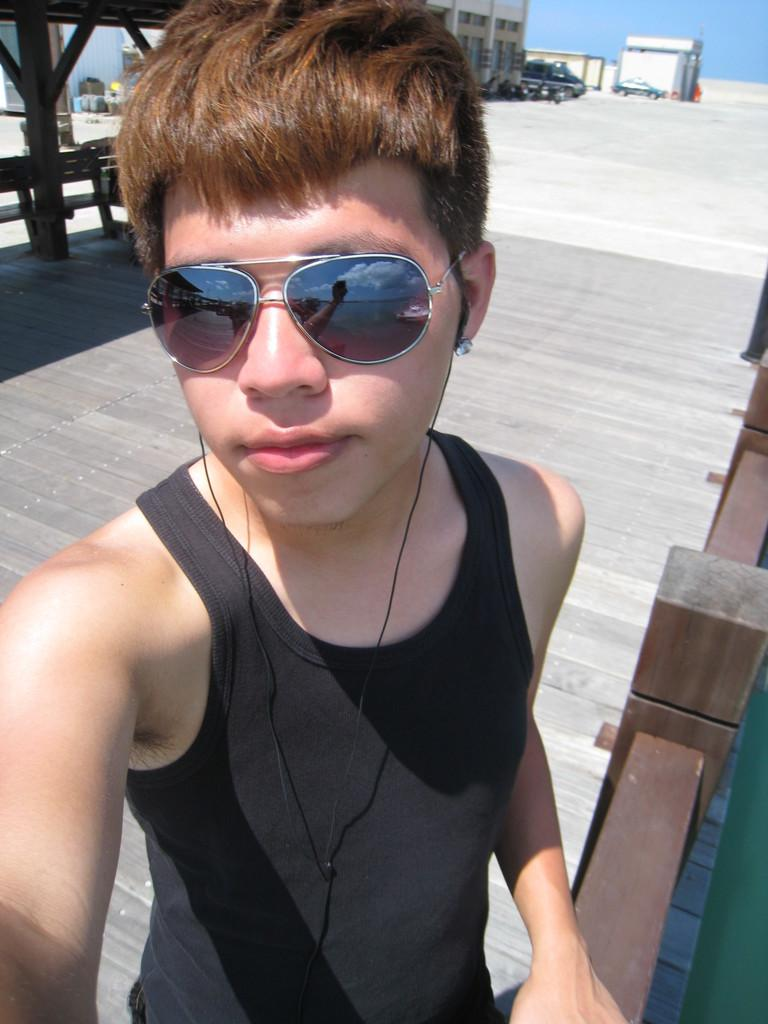What is the main subject of the image? The main subject of the image is a boy standing in the middle of the image. What is the boy wearing on his face? The boy is wearing goggles. What can be seen in the background of the image? The sky is visible in the background of the image. What type of structures are visible at the top of the image? There are buildings visible at the top of the image. How many cakes can be seen on the boy's head in the image? There are no cakes present on the boy's head in the image. Can you describe the boy's ability to jump in the image? The image does not show the boy jumping or provide any information about his jumping ability. 